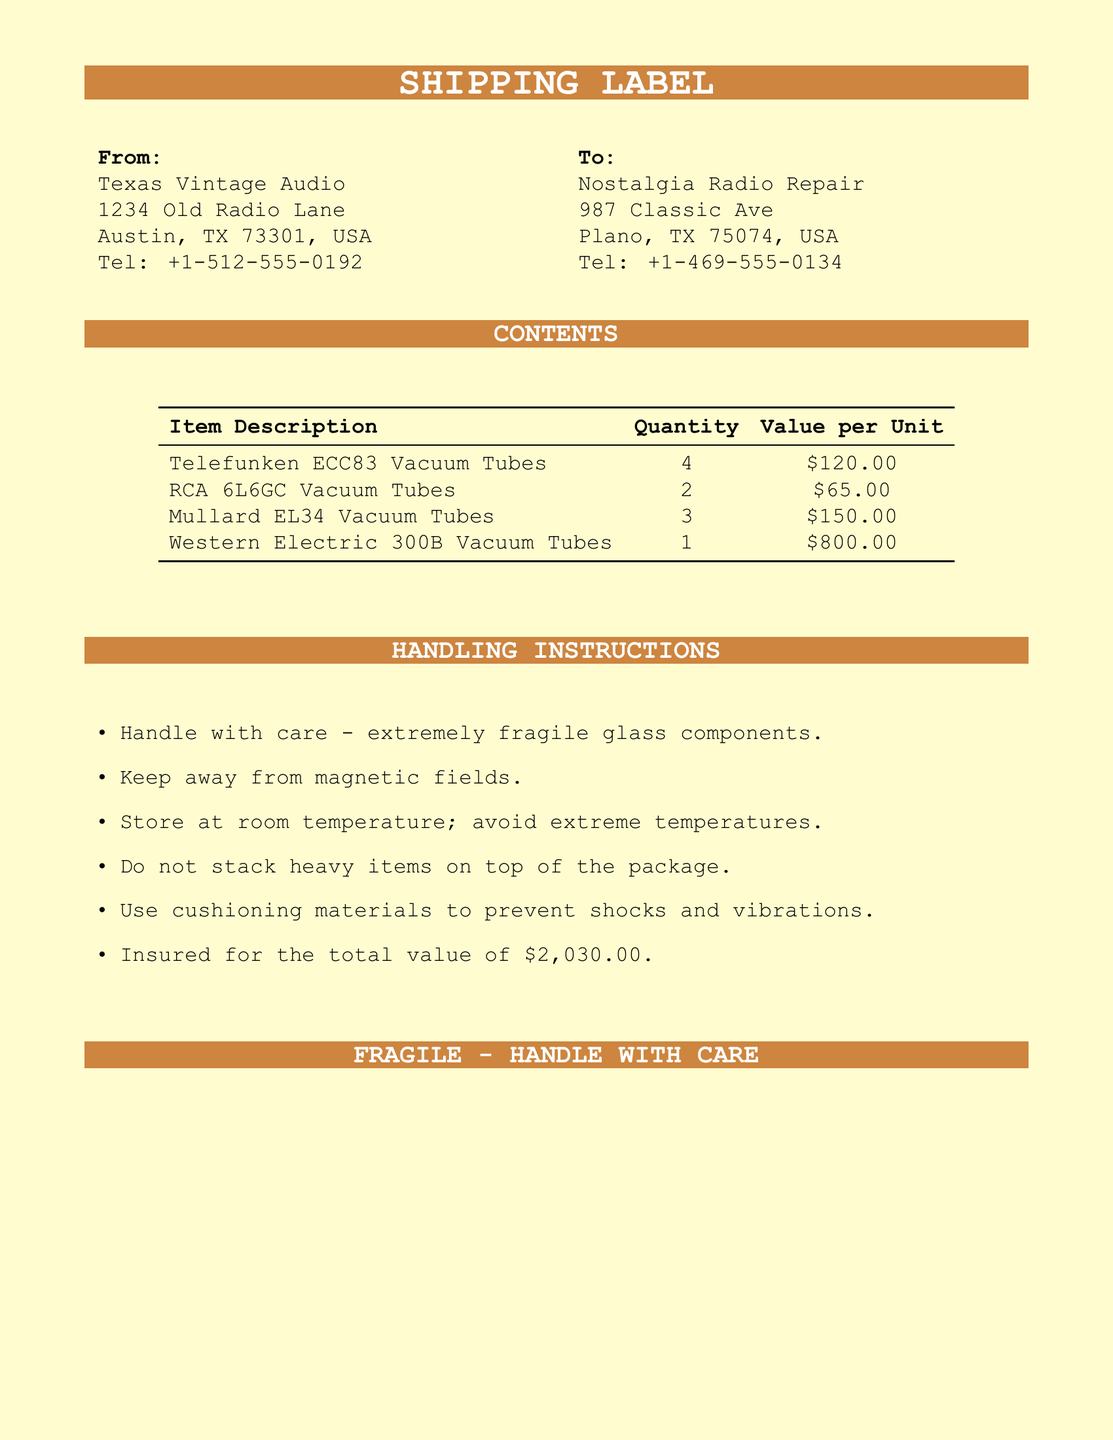What is the sender's name? The sender's name is located at the top of the shipping label.
Answer: Texas Vintage Audio What is the receiver's phone number? The receiver's phone number is listed in the receiver's address section.
Answer: +1-469-555-0134 How many Telefunken ECC83 vacuum tubes are included? The quantity of Telefunken ECC83 vacuum tubes is listed in the contents section of the document.
Answer: 4 What is the total insured value of the shipment? The total insured value is specified in the handling instructions.
Answer: $2,030.00 What is one handling instruction for the package? The handling instructions are listed as bullet points in the document.
Answer: Handle with care - extremely fragile glass components How many different types of vacuum tubes are included in this shipment? The document lists each type of vacuum tube under contents.
Answer: 4 What item has the highest individual value? The item with the highest price per unit is identified in the contents section.
Answer: Western Electric 300B Vacuum Tubes What city is the sender located in? The sender's city is mentioned in the sender's address section.
Answer: Austin What state is the receiver's address in? The state in the receiver's address is highlighted in the shipping label.
Answer: TX 